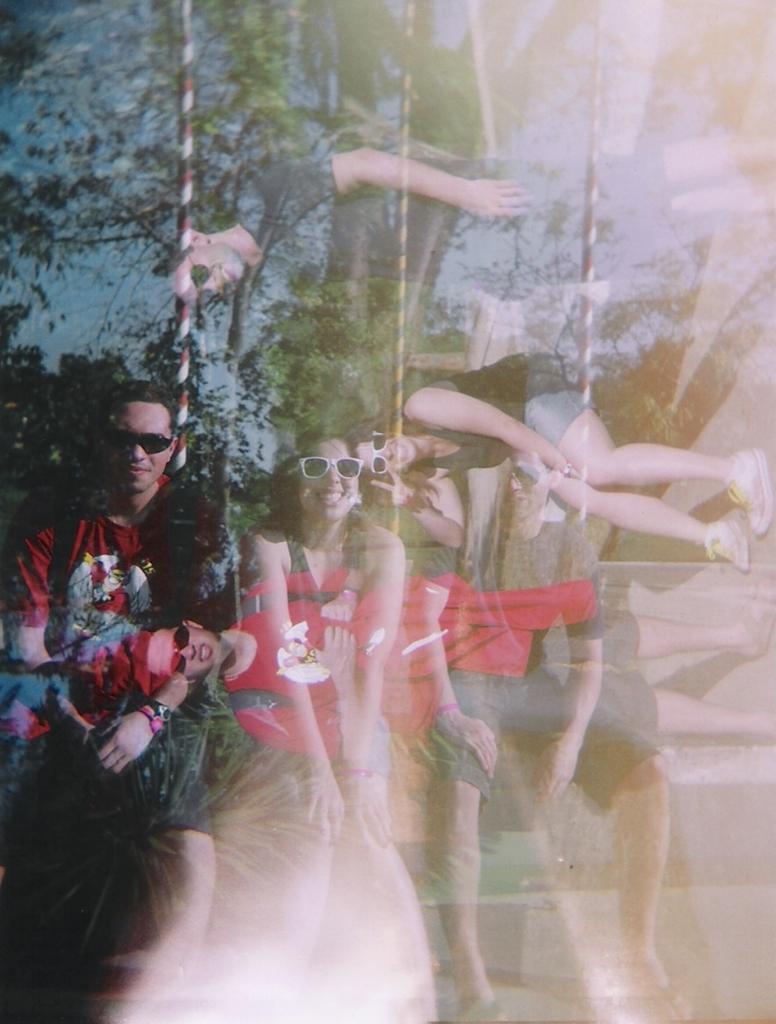Please provide a concise description of this image. In this image I can see the glass surface and on the glass surface I can see the reflection of few trees, few persons and the sky. Through the glass surface I can see few persons. 